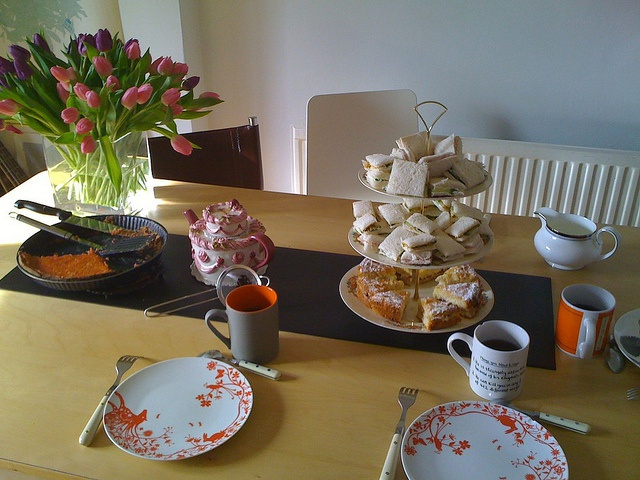Describe the objects in this image and their specific colors. I can see dining table in darkgreen, tan, and olive tones, bowl in darkgreen, black, brown, and maroon tones, chair in darkgreen and gray tones, vase in darkgreen, olive, ivory, darkgray, and khaki tones, and sandwich in darkgreen, darkgray, and gray tones in this image. 